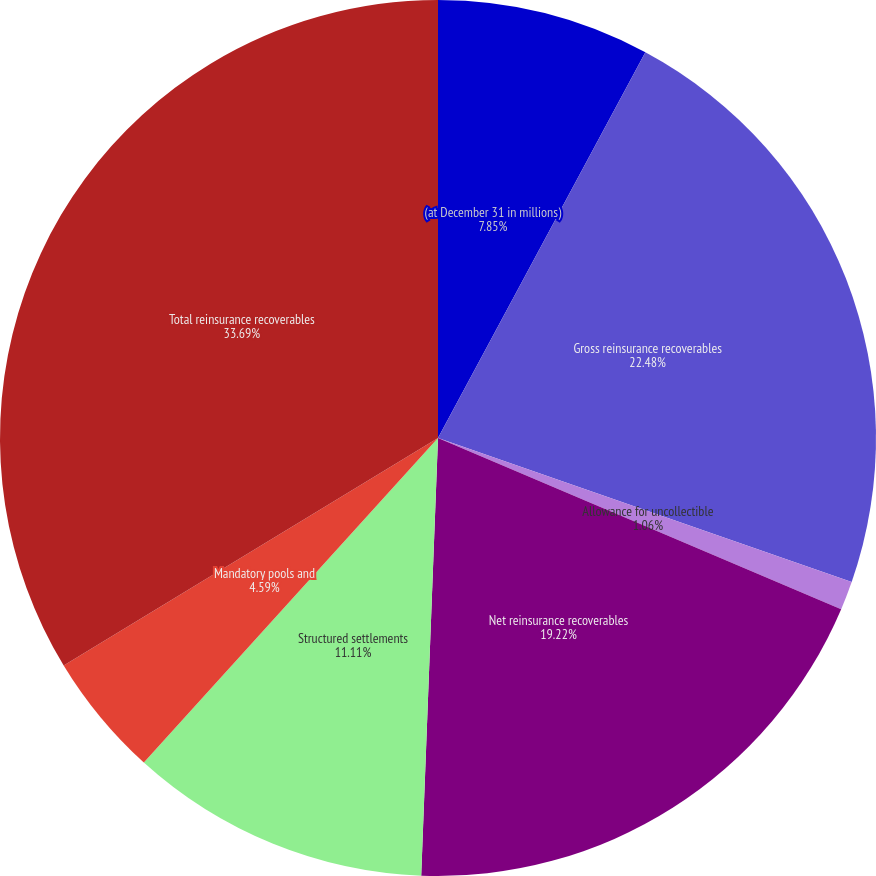Convert chart to OTSL. <chart><loc_0><loc_0><loc_500><loc_500><pie_chart><fcel>(at December 31 in millions)<fcel>Gross reinsurance recoverables<fcel>Allowance for uncollectible<fcel>Net reinsurance recoverables<fcel>Structured settlements<fcel>Mandatory pools and<fcel>Total reinsurance recoverables<nl><fcel>7.85%<fcel>22.48%<fcel>1.06%<fcel>19.22%<fcel>11.11%<fcel>4.59%<fcel>33.69%<nl></chart> 